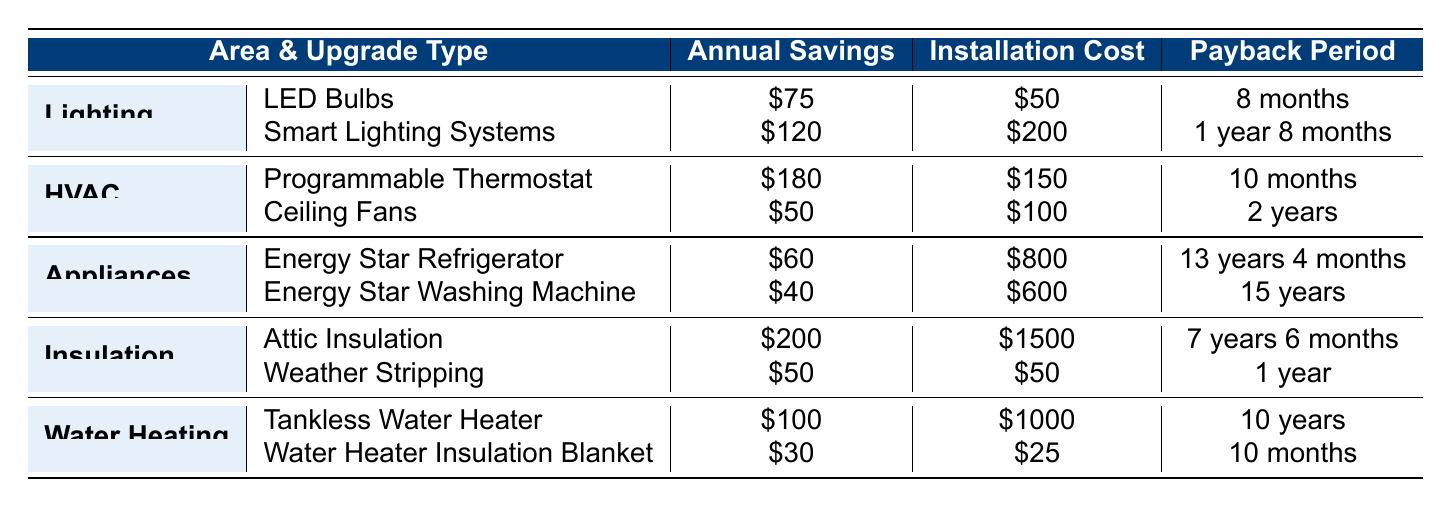What is the total annual savings from upgrading to a programmable thermostat and attic insulation? The annual savings from a programmable thermostat is $180, and from attic insulation, it is $200. Adding these two values gives $180 + $200 = $380.
Answer: $380 Which upgrade has the shortest payback period among all listed? Looking at the payback periods in the table, LED bulbs have a payback period of 8 months, which is less than the others listed.
Answer: LED Bulbs Is the installation cost for Energy Star appliances higher or lower than that for insulation upgrades? The installation costs for Energy Star Refrigerator and Washing Machine are $800 and $600, respectively, totaling $1400. The attic insulation costs $1500 and weather stripping $50, totaling $1550, which is higher.
Answer: Higher What is the average payback period for the upgrades in the HVAC section? The payback periods for the HVAC upgrades are 10 months and 2 years. Converting 2 years to months gives 24 months. The total is 10 + 24 = 34 months. The average is 34/2 = 17 months.
Answer: 17 months Which upgrade offers the lowest annual savings, and what is that amount? The lowest annual savings among the upgrades is from the Energy Star Washing Machine at $40.
Answer: $40 If I install the weather stripping, how long will it take for the savings to cover the installation cost? The installation cost for weather stripping is $50, and the annual savings are $50. Thus, it will take 1 year to cover the cost.
Answer: 1 year What is the total installation cost for all upgrades in the Lighting area? The installation costs in the Lighting area are $50 for LED bulbs and $200 for smart lighting systems. Adding these gives $50 + $200 = $250.
Answer: $250 Is the payback period for the tankless water heater shorter than that for the Energy Star Refrigerator? The payback period for the tankless water heater is 10 years, while the Energy Star Refrigerator has a payback period of 13 years and 4 months. Ten years is shorter than 13 years and 4 months.
Answer: Yes Calculate the difference in annual savings between the attic insulation and water heater insulation blanket. The annual savings for attic insulation is $200, and for the water heater insulation blanket, it is $30. The difference is $200 - $30 = $170.
Answer: $170 Which area has the highest total annual savings from all its upgrades combined? For the area of HVAC, the total annual savings is $180 + $50 = $230. For insulation, it is $200 + $50 = $250. Thus, the area of insulation has the highest savings at $250.
Answer: Insulation 